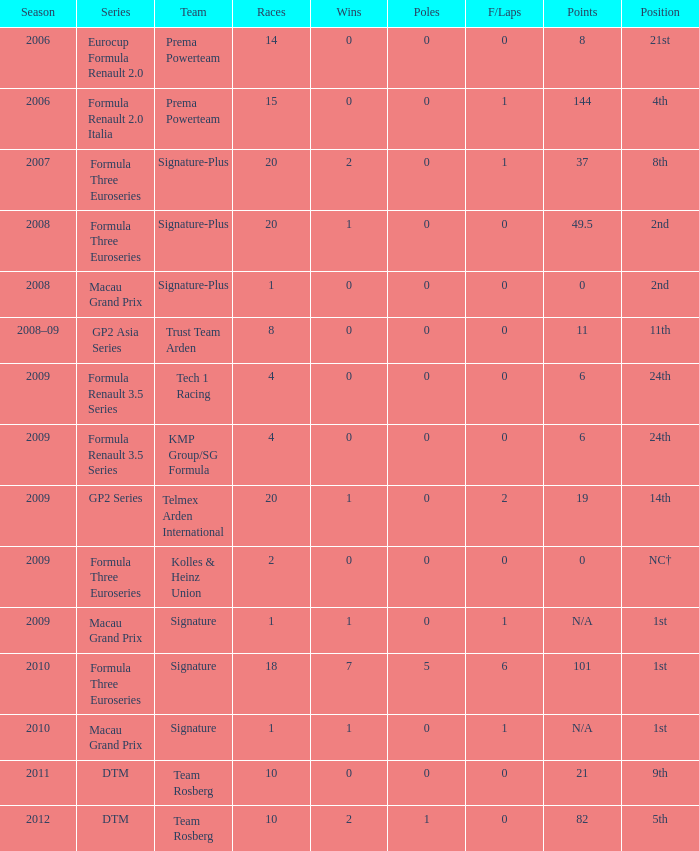Which sequence contains 11 elements? GP2 Asia Series. 